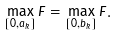Convert formula to latex. <formula><loc_0><loc_0><loc_500><loc_500>\max _ { [ 0 , a _ { k } ] } F = \max _ { [ 0 , b _ { k } ] } F .</formula> 